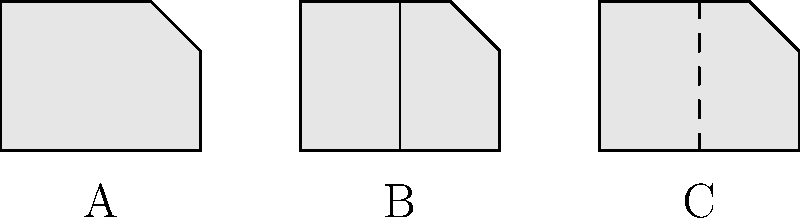As a filmmaker documenting American antiques, you come across three cross-sectional views of antique firearms. Based on the characteristics shown in the diagram, identify which cross-section (A, B, or C) represents a percussion cap revolver. To identify the percussion cap revolver, let's analyze each cross-section:

1. Cross-section A:
   - Shows a single chamber
   - No visible cylinder or separate chambers
   - Likely represents a flintlock pistol or early single-shot firearm

2. Cross-section B:
   - Shows multiple chambers in a cylindrical arrangement
   - The central line indicates the presence of a cylinder
   - This is characteristic of a percussion cap revolver

3. Cross-section C:
   - Shows a single chamber with a hinged or opening breech
   - The dashed line suggests a breech-loading mechanism
   - Likely represents a breech-loading rifle or shotgun

The percussion cap revolver, developed in the mid-19th century, was a significant advancement in firearm technology. It featured a revolving cylinder with multiple chambers, allowing for quicker successive shots compared to single-shot firearms.

Based on these observations, cross-section B clearly represents the percussion cap revolver due to its multiple chambers arranged in a cylinder.
Answer: B 